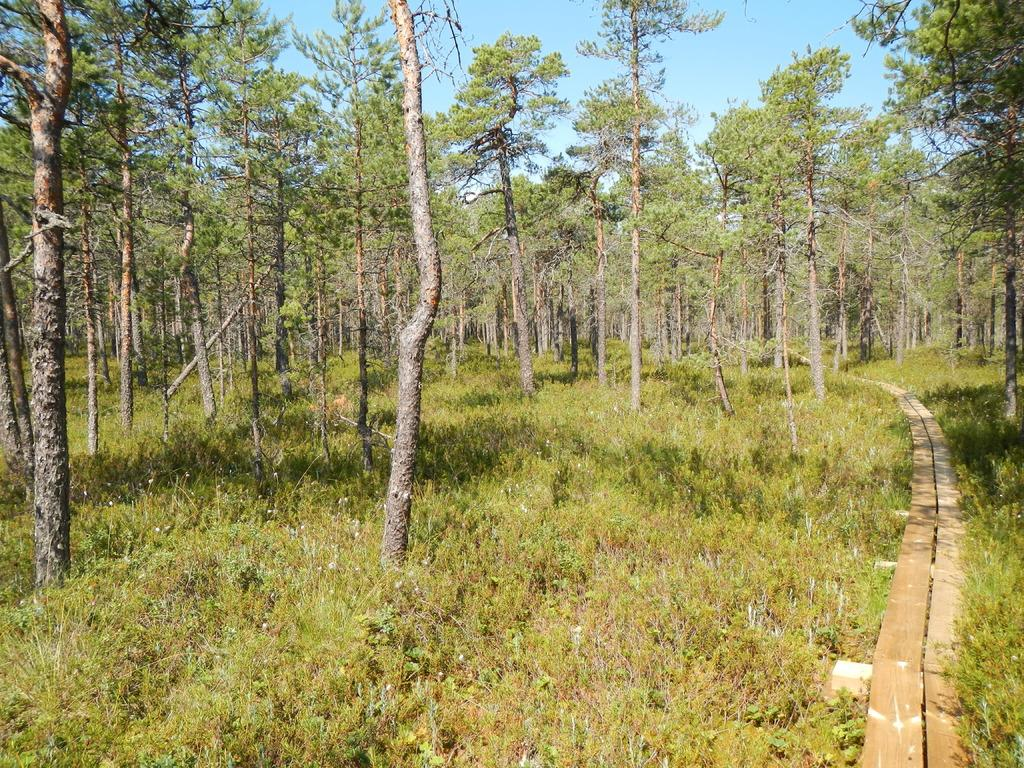What type of living organisms can be seen in the image? Plants, grass, and trees can be seen in the image. What is the color of the sky in the image? The sky is visible in the image and is blue in color. What type of disease can be seen affecting the plants in the image? There is no indication of any disease affecting the plants in the image. What type of cakes are being served in the image? There are no cakes present in the image. Can you spot a tiger hiding among the trees in the image? There is no tiger present in the image. 